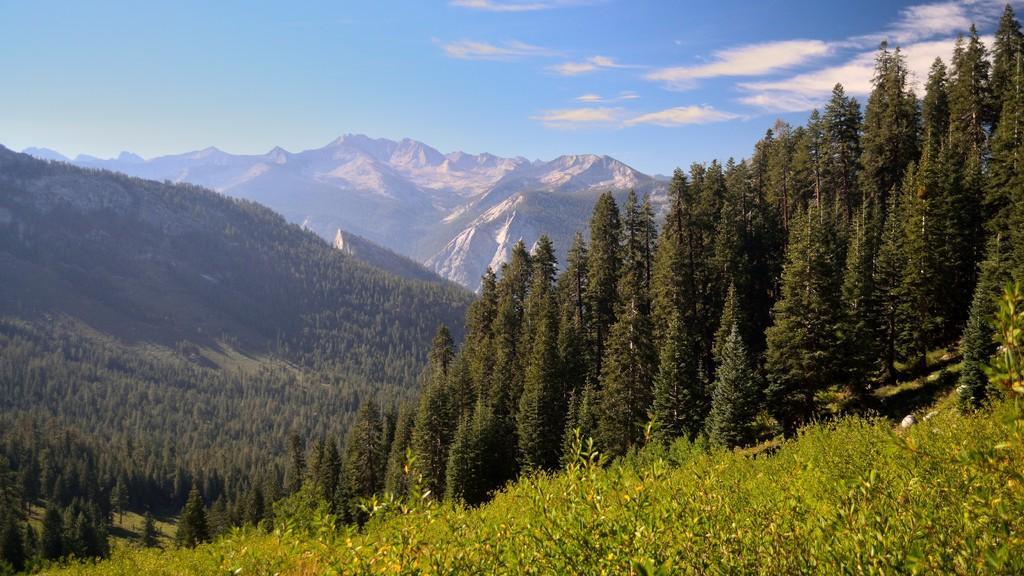Can you describe this image briefly? In this image I can see few trees which are green in color on the ground. In the background I can see few mountains, few trees on the mountains and the sky. 